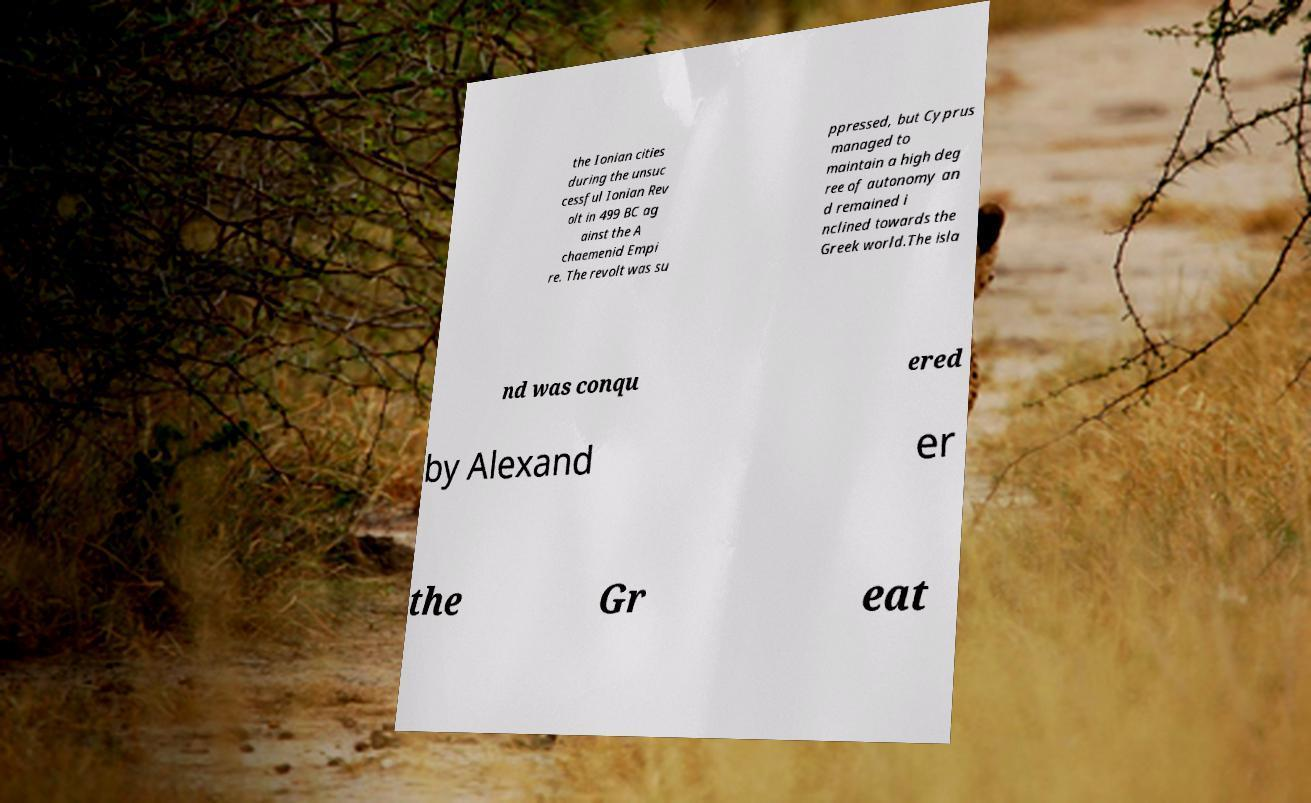Please identify and transcribe the text found in this image. the Ionian cities during the unsuc cessful Ionian Rev olt in 499 BC ag ainst the A chaemenid Empi re. The revolt was su ppressed, but Cyprus managed to maintain a high deg ree of autonomy an d remained i nclined towards the Greek world.The isla nd was conqu ered by Alexand er the Gr eat 